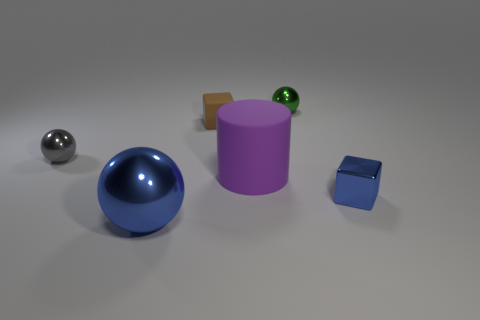The block behind the big thing that is behind the small shiny thing that is on the right side of the tiny green ball is what color?
Make the answer very short. Brown. There is a big sphere that is in front of the gray metallic object; does it have the same color as the cube that is to the right of the tiny brown cube?
Give a very brief answer. Yes. There is a tiny cube that is in front of the large purple rubber cylinder; how many tiny things are to the left of it?
Ensure brevity in your answer.  3. Are any small blue shiny things visible?
Your response must be concise. Yes. How many other objects are the same color as the large metal thing?
Your response must be concise. 1. Is the number of green balls less than the number of tiny yellow rubber balls?
Make the answer very short. No. What shape is the thing on the left side of the blue object left of the green metal ball?
Provide a succinct answer. Sphere. Are there any balls right of the large blue ball?
Provide a succinct answer. Yes. There is a sphere that is the same size as the purple matte cylinder; what color is it?
Keep it short and to the point. Blue. How many purple objects have the same material as the tiny brown cube?
Keep it short and to the point. 1. 